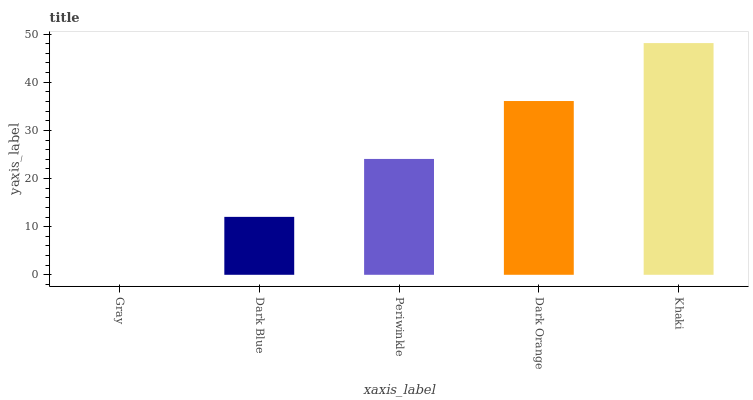Is Gray the minimum?
Answer yes or no. Yes. Is Khaki the maximum?
Answer yes or no. Yes. Is Dark Blue the minimum?
Answer yes or no. No. Is Dark Blue the maximum?
Answer yes or no. No. Is Dark Blue greater than Gray?
Answer yes or no. Yes. Is Gray less than Dark Blue?
Answer yes or no. Yes. Is Gray greater than Dark Blue?
Answer yes or no. No. Is Dark Blue less than Gray?
Answer yes or no. No. Is Periwinkle the high median?
Answer yes or no. Yes. Is Periwinkle the low median?
Answer yes or no. Yes. Is Khaki the high median?
Answer yes or no. No. Is Gray the low median?
Answer yes or no. No. 